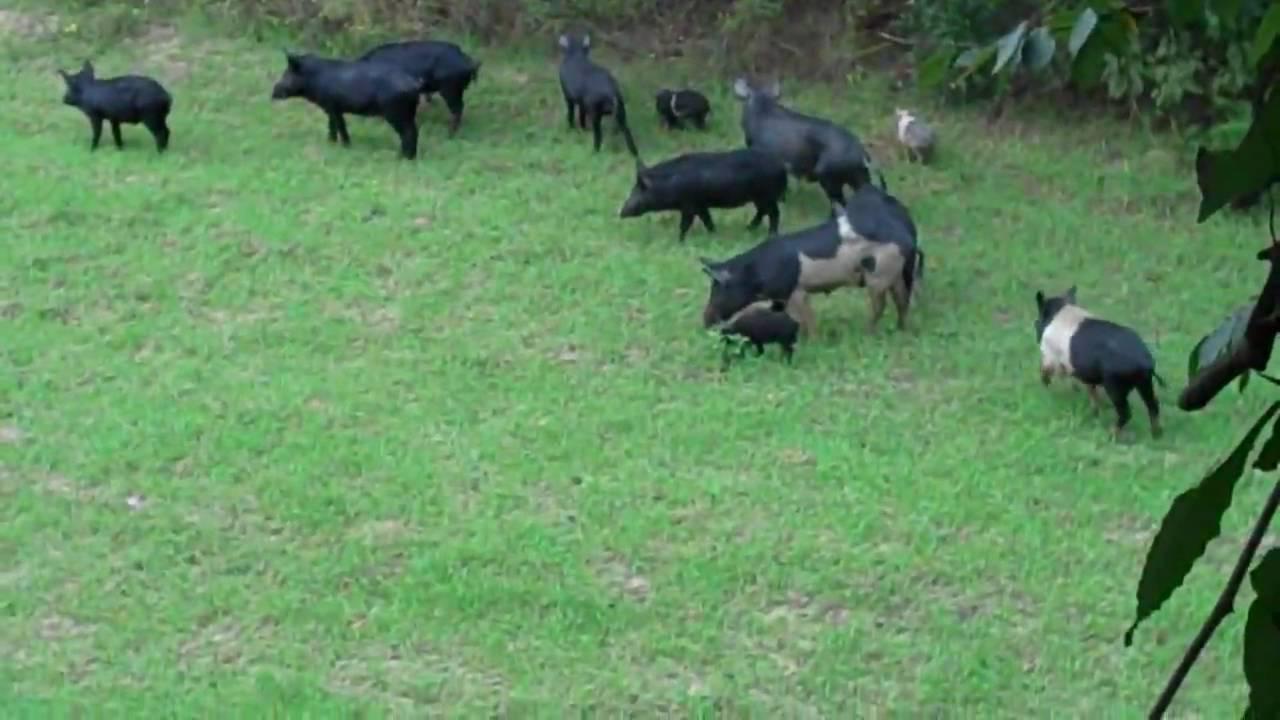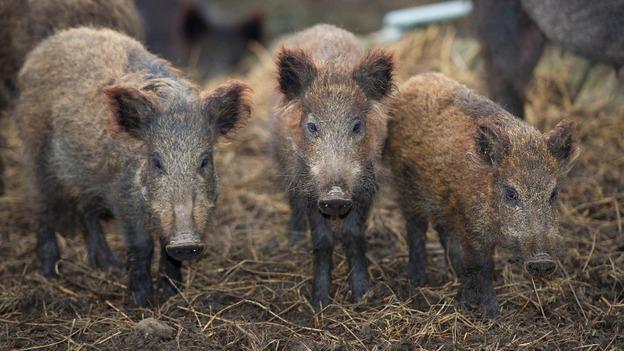The first image is the image on the left, the second image is the image on the right. Evaluate the accuracy of this statement regarding the images: "An image contains no more than 8 hogs, with at least half standing facing forward.". Is it true? Answer yes or no. Yes. 